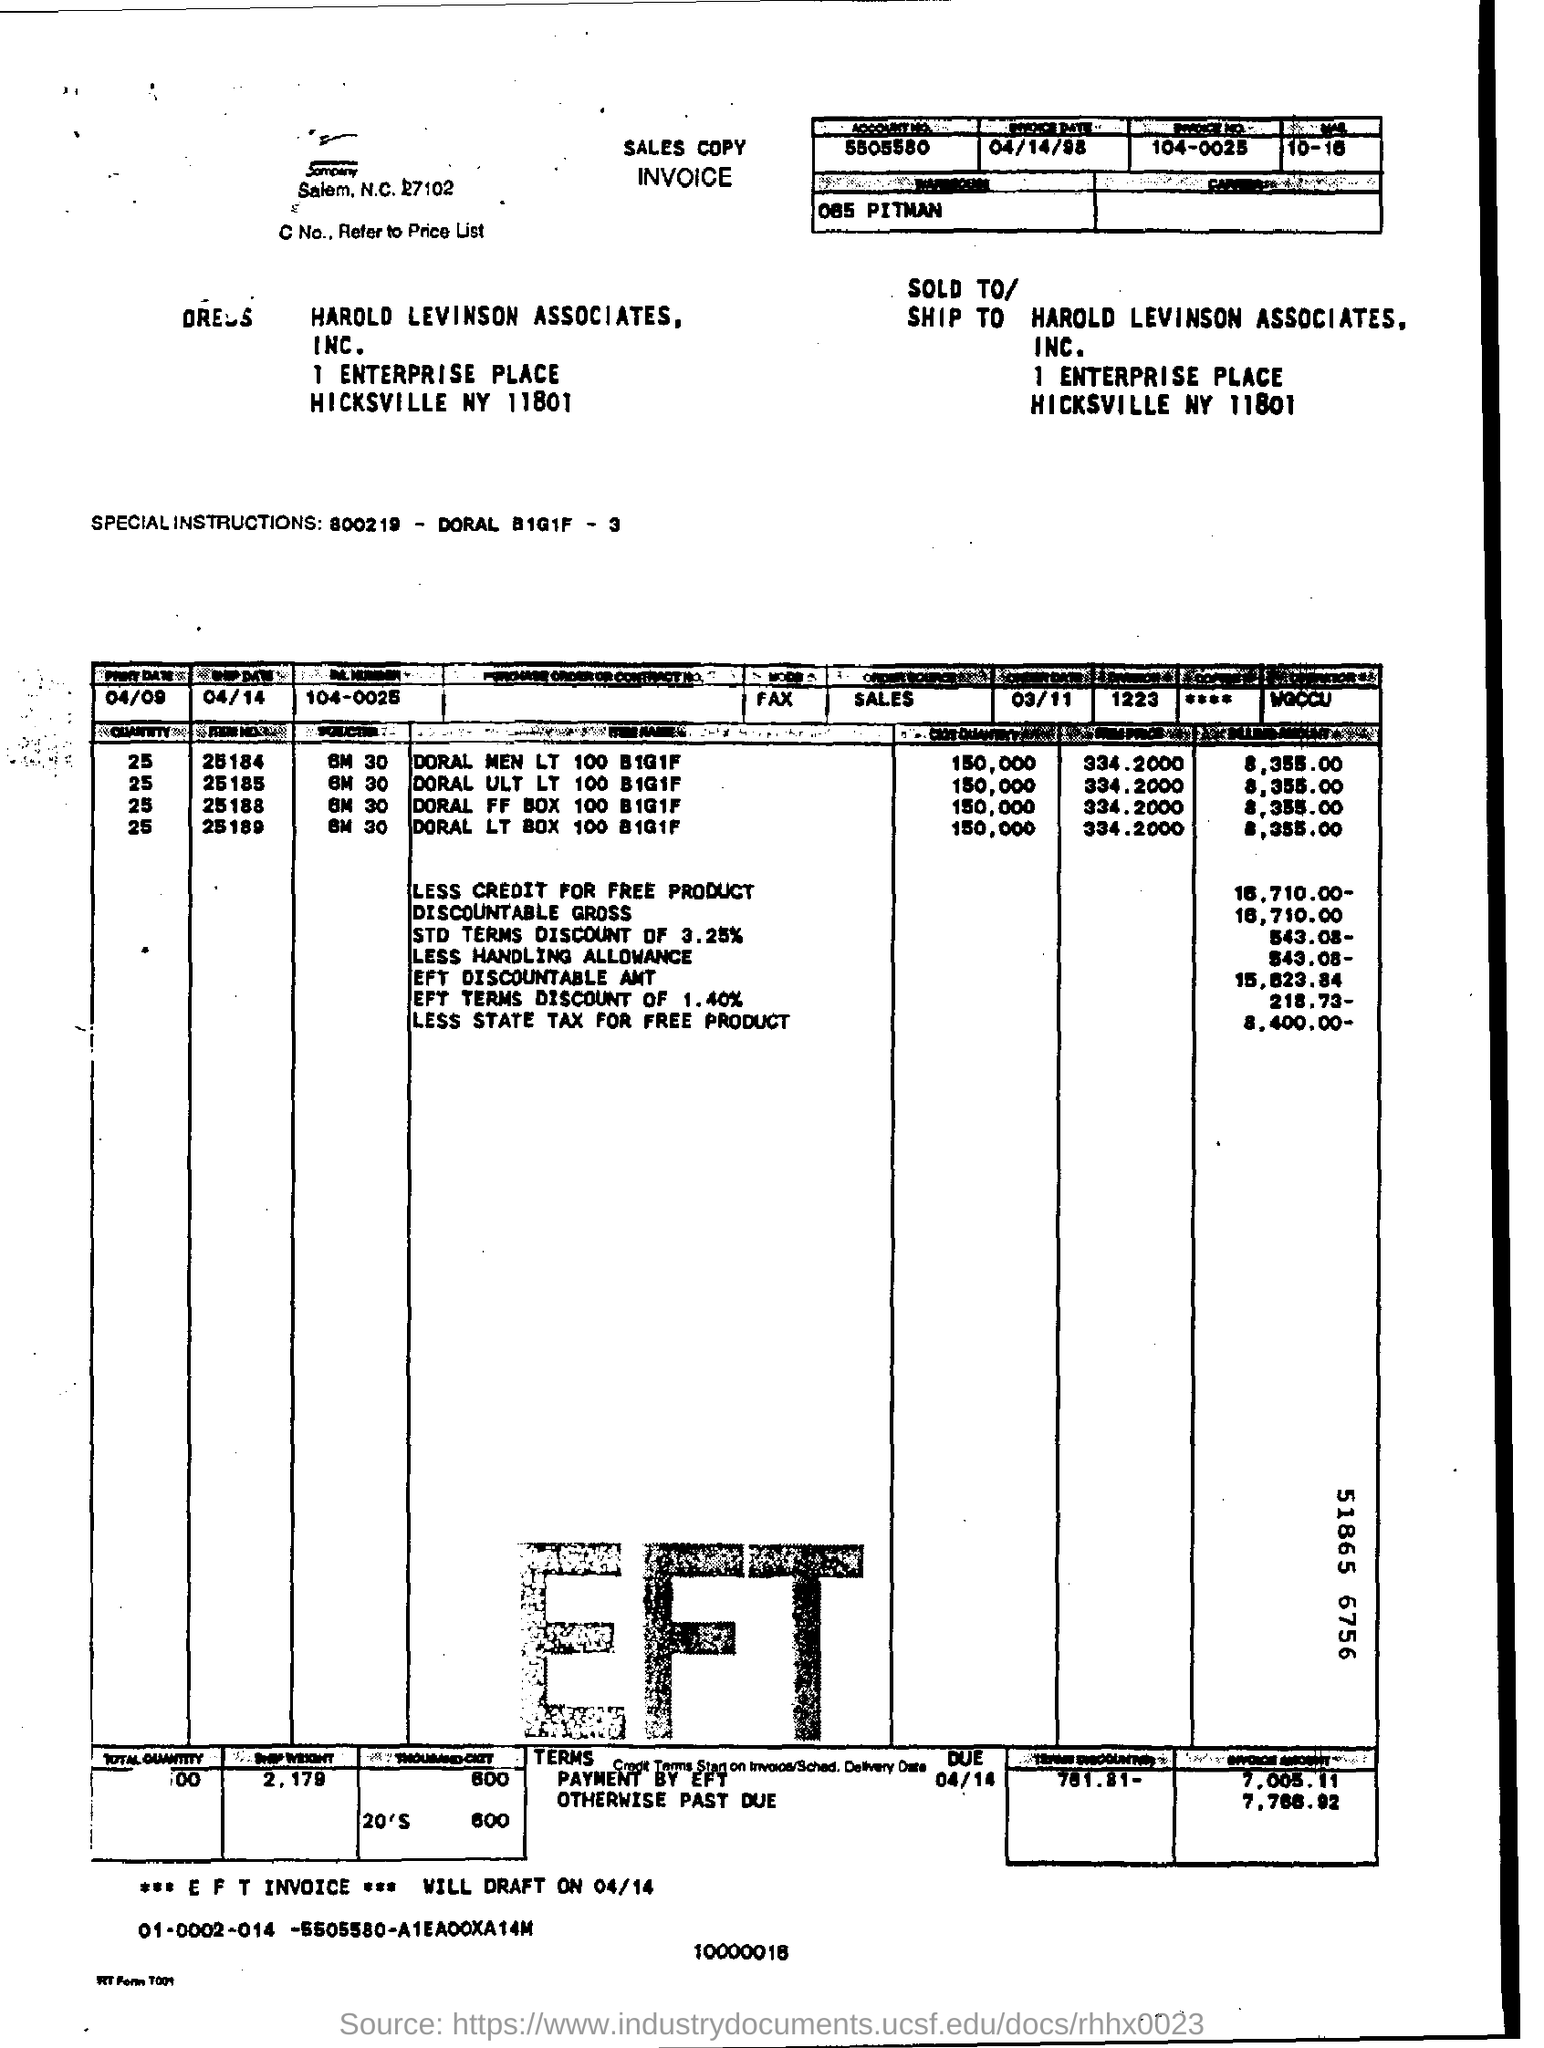Outline some significant characteristics in this image. Could you please provide your account number, which is 5505580...? The invoice date is April 14, 1998. 